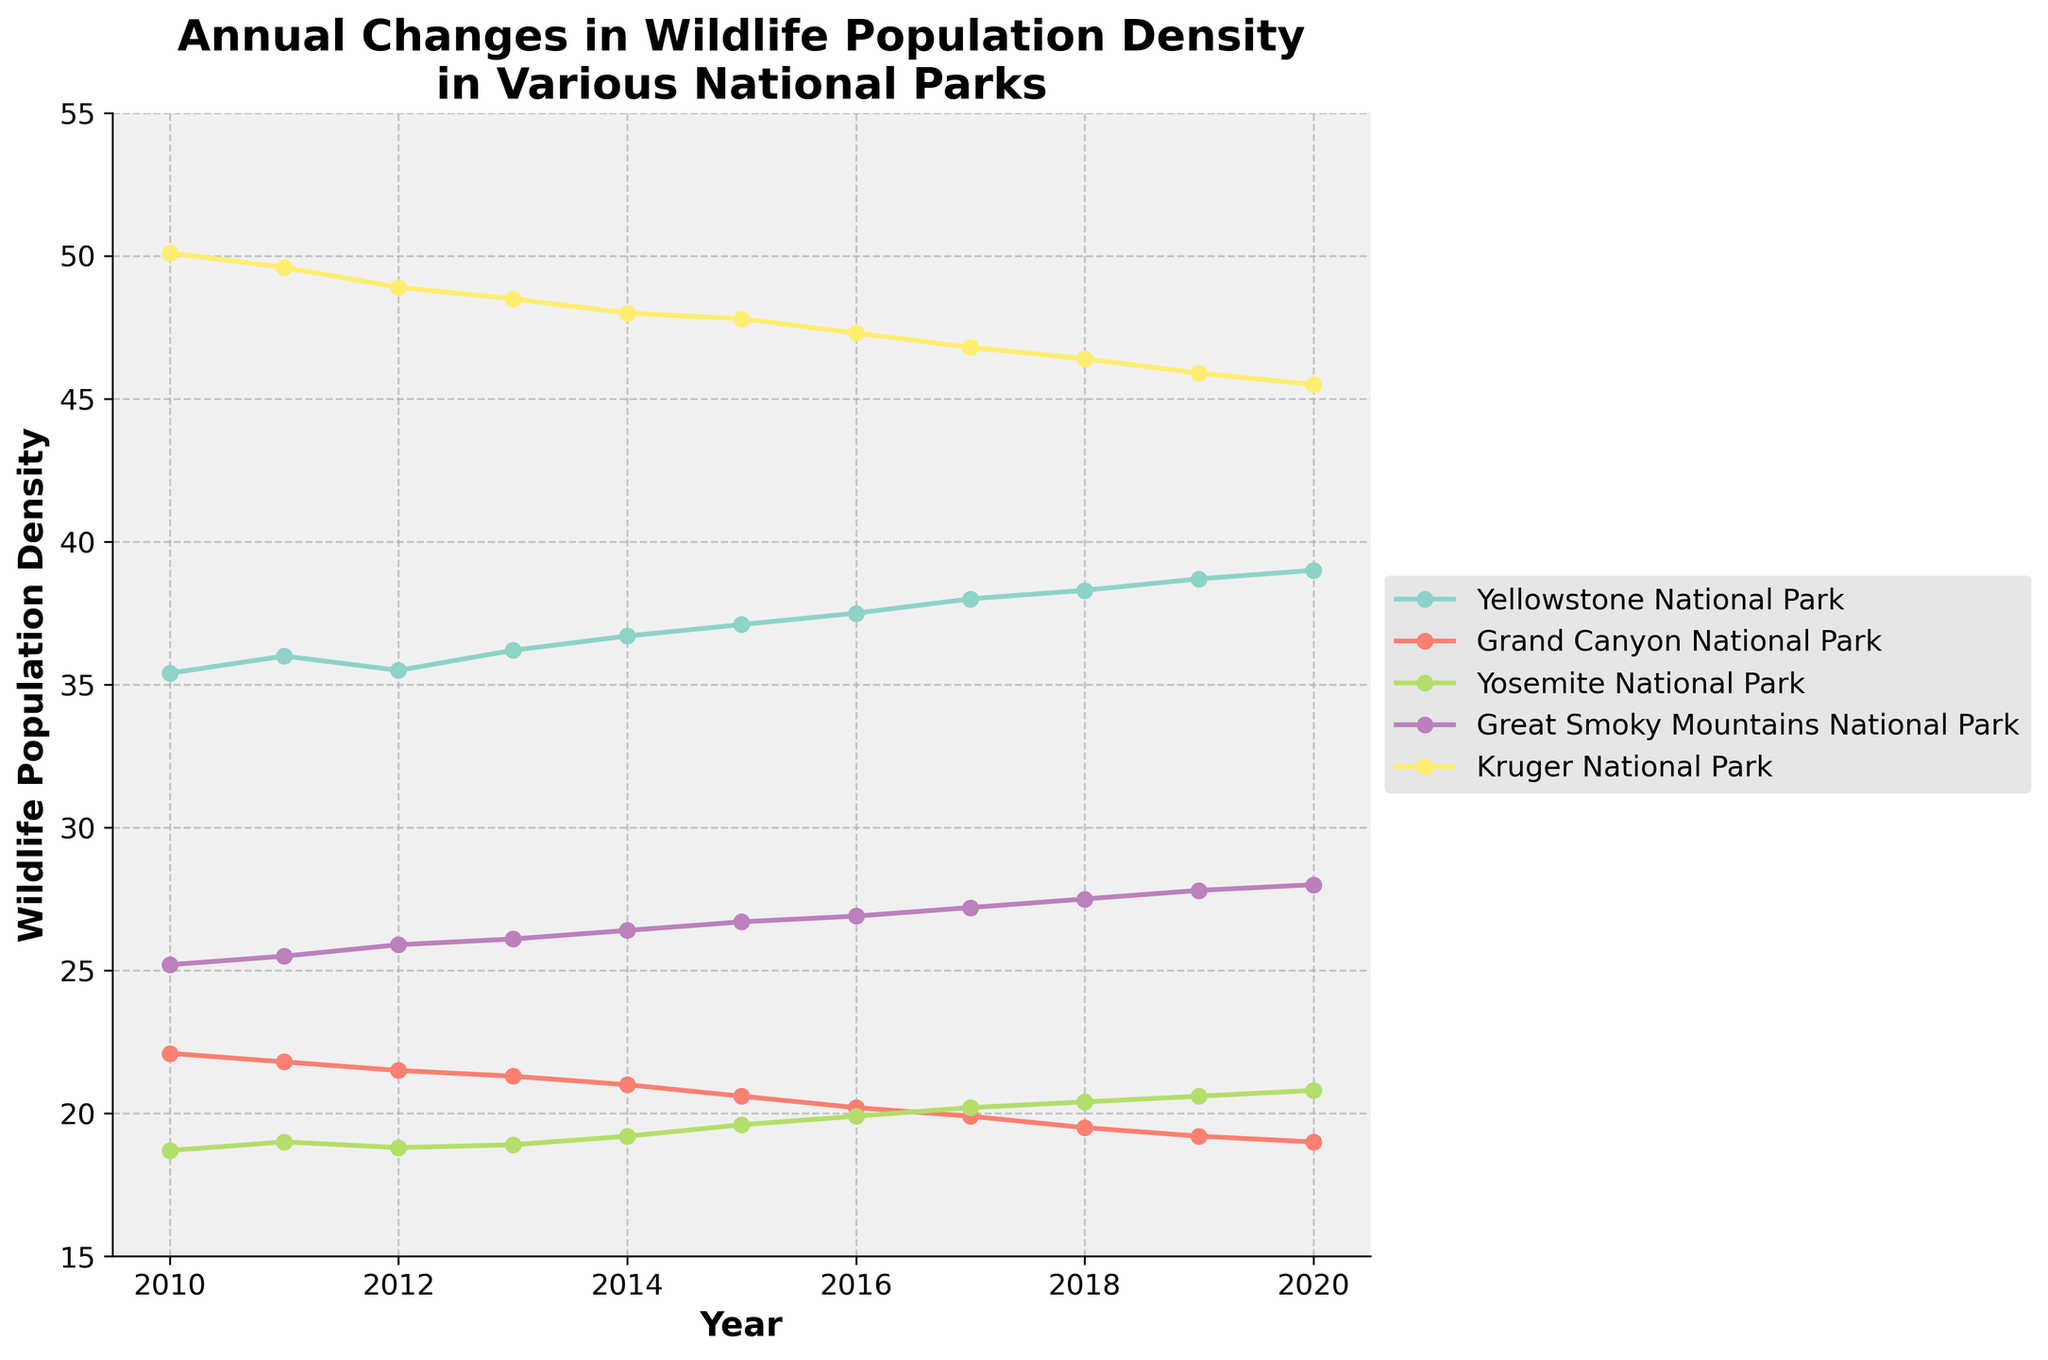What is the title of the figure? The title is usually at the top of the figure. In this case, it reads "Annual Changes in Wildlife Population Density in Various National Parks."
Answer: Annual Changes in Wildlife Population Density in Various National Parks Which park had the highest wildlife population density in 2020? By looking at the data points for the year 2020 across all lines representing different parks, the highest data point belongs to Kruger National Park.
Answer: Kruger National Park In which year did Yellowstone National Park first surpass a population density of 38? By following the trend of Yellowstone National Park and checking when it crosses the 38 on the y-axis, the first occurrence is in 2017.
Answer: 2017 What is the general trend of wildlife population density in Grand Canyon National Park over the years? Observing the data points for Grand Canyon National Park from 2010 to 2020, one can see a general decreasing trend.
Answer: Decreasing Compare the wildlife population density trend between Great Smoky Mountains National Park and Yosemite National Park. Great Smoky Mountains National Park shows a consistent increase, while Yosemite National Park shows a slower, but also increasing trend.
Answer: Both increasing, but Great Smoky Mountains National Park is increasing faster Which park showed the most consistent increase in wildlife population density over the years? By comparing the slopes of the lines, Yellowstone National Park exhibits the most consistent increase without apparent fluctuations.
Answer: Yellowstone National Park What was the approximate wildlife population density in Kruger National Park in 2015? Locate the 2015 data point on the Kruger National Park line, which intersects at around 47.8 on the y-axis.
Answer: 47.8 Calculate the average wildlife population density for Great Smoky Mountains National Park over the given period. Sum the population densities from 2010 to 2020 for Great Smoky Mountains National Park (25.2, 25.5, 25.9, 26.1, 26.4, 26.7, 26.9, 27.2, 27.5, 27.8, 28.0) which equals 292.2, then divide by the number of years (11).
Answer: 26.56 